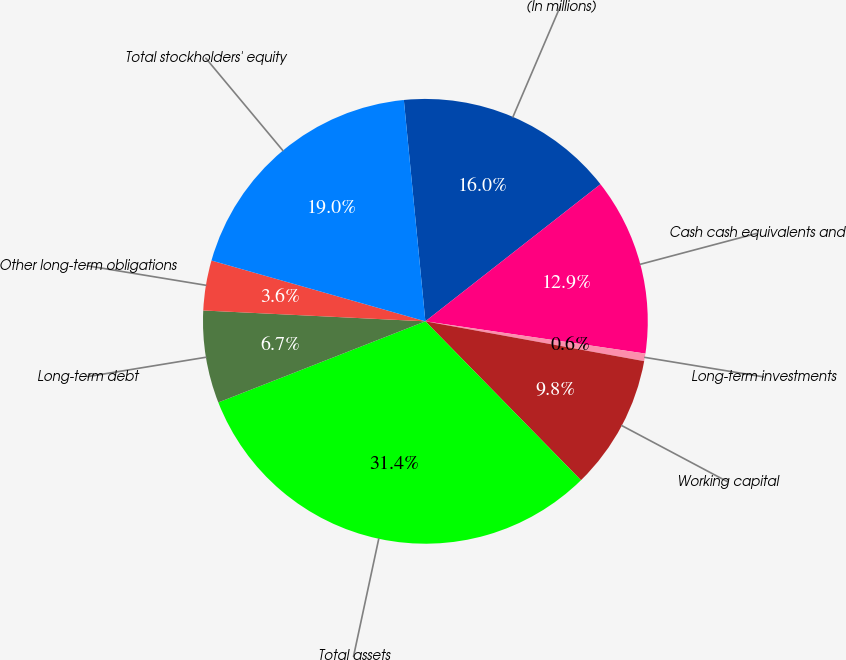Convert chart to OTSL. <chart><loc_0><loc_0><loc_500><loc_500><pie_chart><fcel>(In millions)<fcel>Cash cash equivalents and<fcel>Long-term investments<fcel>Working capital<fcel>Total assets<fcel>Long-term debt<fcel>Other long-term obligations<fcel>Total stockholders' equity<nl><fcel>15.97%<fcel>12.89%<fcel>0.55%<fcel>9.8%<fcel>31.39%<fcel>6.72%<fcel>3.63%<fcel>19.05%<nl></chart> 